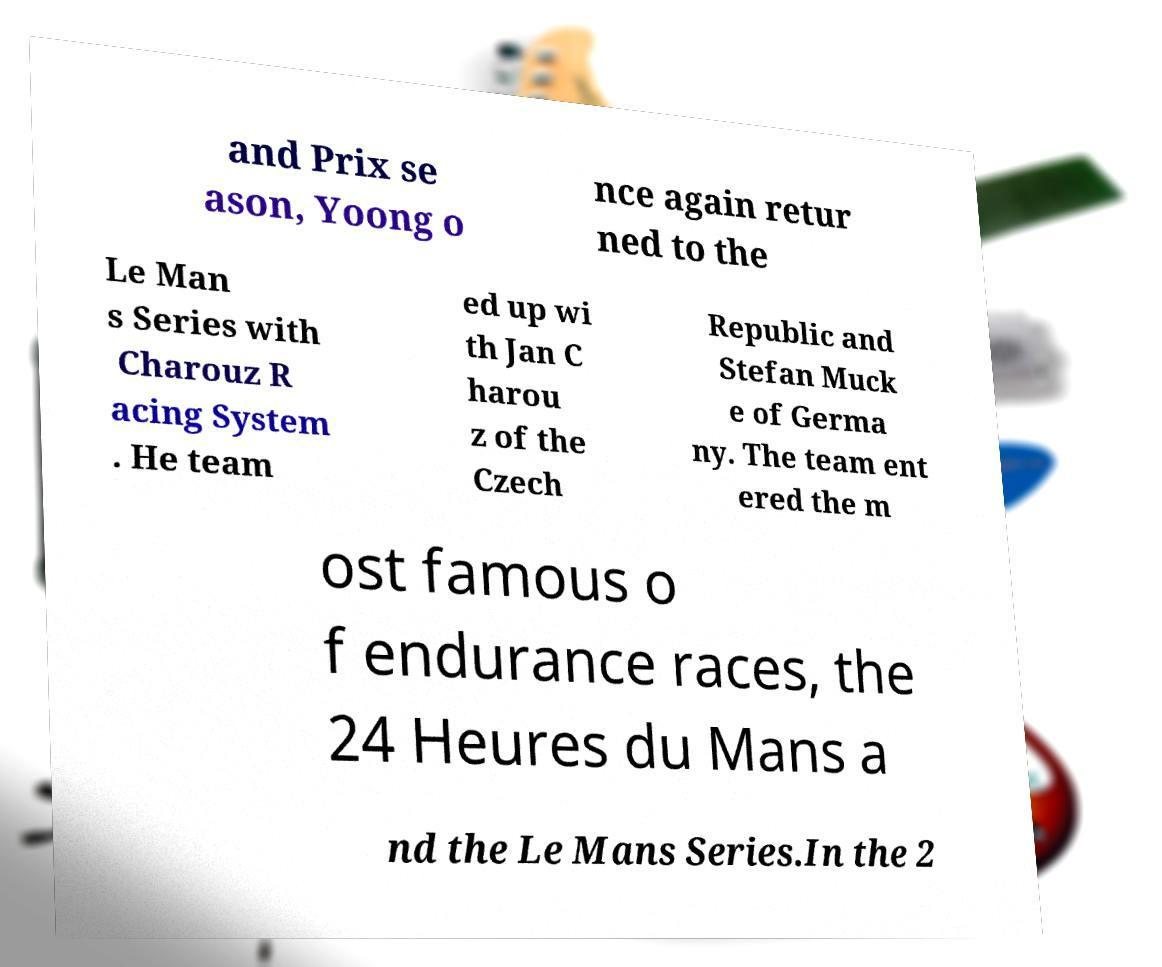What messages or text are displayed in this image? I need them in a readable, typed format. and Prix se ason, Yoong o nce again retur ned to the Le Man s Series with Charouz R acing System . He team ed up wi th Jan C harou z of the Czech Republic and Stefan Muck e of Germa ny. The team ent ered the m ost famous o f endurance races, the 24 Heures du Mans a nd the Le Mans Series.In the 2 